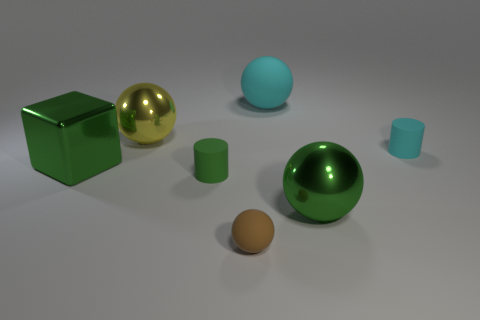Add 2 green balls. How many objects exist? 9 Subtract all cubes. How many objects are left? 6 Subtract 0 purple cylinders. How many objects are left? 7 Subtract all yellow metallic cylinders. Subtract all yellow metal objects. How many objects are left? 6 Add 6 matte balls. How many matte balls are left? 8 Add 7 tiny cyan matte things. How many tiny cyan matte things exist? 8 